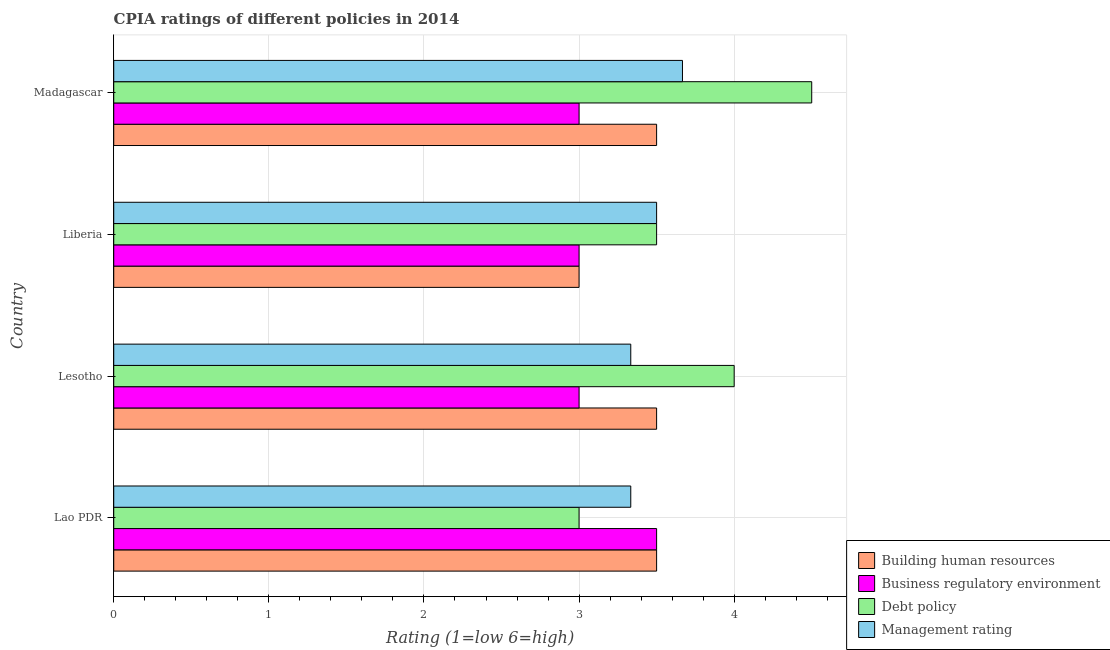How many different coloured bars are there?
Keep it short and to the point. 4. How many bars are there on the 3rd tick from the bottom?
Offer a terse response. 4. What is the label of the 1st group of bars from the top?
Your response must be concise. Madagascar. In how many cases, is the number of bars for a given country not equal to the number of legend labels?
Your response must be concise. 0. What is the cpia rating of building human resources in Lesotho?
Give a very brief answer. 3.5. Across all countries, what is the maximum cpia rating of business regulatory environment?
Give a very brief answer. 3.5. Across all countries, what is the minimum cpia rating of debt policy?
Provide a succinct answer. 3. In which country was the cpia rating of debt policy maximum?
Your response must be concise. Madagascar. In which country was the cpia rating of business regulatory environment minimum?
Offer a very short reply. Lesotho. What is the total cpia rating of management in the graph?
Give a very brief answer. 13.83. What is the difference between the cpia rating of building human resources in Lesotho and that in Liberia?
Your answer should be compact. 0.5. What is the difference between the cpia rating of debt policy in Madagascar and the cpia rating of business regulatory environment in Liberia?
Offer a terse response. 1.5. What is the average cpia rating of building human resources per country?
Give a very brief answer. 3.38. In how many countries, is the cpia rating of management greater than 3.6 ?
Offer a terse response. 1. What is the ratio of the cpia rating of building human resources in Lao PDR to that in Madagascar?
Give a very brief answer. 1. Is the cpia rating of debt policy in Lesotho less than that in Madagascar?
Your answer should be compact. Yes. Is the difference between the cpia rating of building human resources in Lesotho and Madagascar greater than the difference between the cpia rating of management in Lesotho and Madagascar?
Your answer should be compact. Yes. Is it the case that in every country, the sum of the cpia rating of debt policy and cpia rating of building human resources is greater than the sum of cpia rating of management and cpia rating of business regulatory environment?
Your answer should be very brief. No. What does the 3rd bar from the top in Lesotho represents?
Give a very brief answer. Business regulatory environment. What does the 1st bar from the bottom in Liberia represents?
Your response must be concise. Building human resources. Are all the bars in the graph horizontal?
Make the answer very short. Yes. How many countries are there in the graph?
Provide a succinct answer. 4. Does the graph contain any zero values?
Your response must be concise. No. How are the legend labels stacked?
Your answer should be very brief. Vertical. What is the title of the graph?
Keep it short and to the point. CPIA ratings of different policies in 2014. What is the label or title of the X-axis?
Provide a short and direct response. Rating (1=low 6=high). What is the label or title of the Y-axis?
Provide a succinct answer. Country. What is the Rating (1=low 6=high) of Management rating in Lao PDR?
Give a very brief answer. 3.33. What is the Rating (1=low 6=high) of Business regulatory environment in Lesotho?
Your answer should be very brief. 3. What is the Rating (1=low 6=high) of Debt policy in Lesotho?
Provide a succinct answer. 4. What is the Rating (1=low 6=high) of Management rating in Lesotho?
Provide a succinct answer. 3.33. What is the Rating (1=low 6=high) in Business regulatory environment in Liberia?
Your answer should be compact. 3. What is the Rating (1=low 6=high) in Debt policy in Liberia?
Make the answer very short. 3.5. What is the Rating (1=low 6=high) of Management rating in Liberia?
Your answer should be very brief. 3.5. What is the Rating (1=low 6=high) in Management rating in Madagascar?
Offer a terse response. 3.67. Across all countries, what is the maximum Rating (1=low 6=high) of Management rating?
Keep it short and to the point. 3.67. Across all countries, what is the minimum Rating (1=low 6=high) in Debt policy?
Provide a succinct answer. 3. Across all countries, what is the minimum Rating (1=low 6=high) of Management rating?
Your answer should be very brief. 3.33. What is the total Rating (1=low 6=high) in Building human resources in the graph?
Provide a succinct answer. 13.5. What is the total Rating (1=low 6=high) in Business regulatory environment in the graph?
Keep it short and to the point. 12.5. What is the total Rating (1=low 6=high) of Debt policy in the graph?
Ensure brevity in your answer.  15. What is the total Rating (1=low 6=high) in Management rating in the graph?
Your answer should be very brief. 13.83. What is the difference between the Rating (1=low 6=high) in Business regulatory environment in Lao PDR and that in Lesotho?
Your response must be concise. 0.5. What is the difference between the Rating (1=low 6=high) in Business regulatory environment in Lao PDR and that in Liberia?
Provide a succinct answer. 0.5. What is the difference between the Rating (1=low 6=high) in Management rating in Lao PDR and that in Liberia?
Keep it short and to the point. -0.17. What is the difference between the Rating (1=low 6=high) in Building human resources in Lao PDR and that in Madagascar?
Offer a very short reply. 0. What is the difference between the Rating (1=low 6=high) of Business regulatory environment in Lao PDR and that in Madagascar?
Your answer should be compact. 0.5. What is the difference between the Rating (1=low 6=high) of Debt policy in Lao PDR and that in Madagascar?
Keep it short and to the point. -1.5. What is the difference between the Rating (1=low 6=high) of Building human resources in Lesotho and that in Liberia?
Keep it short and to the point. 0.5. What is the difference between the Rating (1=low 6=high) in Building human resources in Lesotho and that in Madagascar?
Your answer should be very brief. 0. What is the difference between the Rating (1=low 6=high) in Business regulatory environment in Lesotho and that in Madagascar?
Provide a short and direct response. 0. What is the difference between the Rating (1=low 6=high) of Debt policy in Lesotho and that in Madagascar?
Provide a short and direct response. -0.5. What is the difference between the Rating (1=low 6=high) in Business regulatory environment in Liberia and that in Madagascar?
Make the answer very short. 0. What is the difference between the Rating (1=low 6=high) in Building human resources in Lao PDR and the Rating (1=low 6=high) in Business regulatory environment in Lesotho?
Offer a terse response. 0.5. What is the difference between the Rating (1=low 6=high) of Building human resources in Lao PDR and the Rating (1=low 6=high) of Debt policy in Lesotho?
Make the answer very short. -0.5. What is the difference between the Rating (1=low 6=high) of Business regulatory environment in Lao PDR and the Rating (1=low 6=high) of Management rating in Lesotho?
Make the answer very short. 0.17. What is the difference between the Rating (1=low 6=high) in Debt policy in Lao PDR and the Rating (1=low 6=high) in Management rating in Lesotho?
Ensure brevity in your answer.  -0.33. What is the difference between the Rating (1=low 6=high) in Building human resources in Lao PDR and the Rating (1=low 6=high) in Business regulatory environment in Liberia?
Keep it short and to the point. 0.5. What is the difference between the Rating (1=low 6=high) of Building human resources in Lao PDR and the Rating (1=low 6=high) of Debt policy in Liberia?
Offer a very short reply. 0. What is the difference between the Rating (1=low 6=high) in Building human resources in Lao PDR and the Rating (1=low 6=high) in Management rating in Liberia?
Keep it short and to the point. 0. What is the difference between the Rating (1=low 6=high) of Business regulatory environment in Lao PDR and the Rating (1=low 6=high) of Debt policy in Liberia?
Offer a terse response. 0. What is the difference between the Rating (1=low 6=high) in Debt policy in Lao PDR and the Rating (1=low 6=high) in Management rating in Liberia?
Your response must be concise. -0.5. What is the difference between the Rating (1=low 6=high) of Building human resources in Lao PDR and the Rating (1=low 6=high) of Business regulatory environment in Madagascar?
Give a very brief answer. 0.5. What is the difference between the Rating (1=low 6=high) in Building human resources in Lao PDR and the Rating (1=low 6=high) in Debt policy in Madagascar?
Ensure brevity in your answer.  -1. What is the difference between the Rating (1=low 6=high) of Business regulatory environment in Lao PDR and the Rating (1=low 6=high) of Management rating in Madagascar?
Offer a very short reply. -0.17. What is the difference between the Rating (1=low 6=high) of Debt policy in Lao PDR and the Rating (1=low 6=high) of Management rating in Madagascar?
Provide a short and direct response. -0.67. What is the difference between the Rating (1=low 6=high) of Building human resources in Lesotho and the Rating (1=low 6=high) of Debt policy in Liberia?
Keep it short and to the point. 0. What is the difference between the Rating (1=low 6=high) in Business regulatory environment in Lesotho and the Rating (1=low 6=high) in Management rating in Liberia?
Give a very brief answer. -0.5. What is the difference between the Rating (1=low 6=high) of Building human resources in Lesotho and the Rating (1=low 6=high) of Debt policy in Madagascar?
Make the answer very short. -1. What is the difference between the Rating (1=low 6=high) in Business regulatory environment in Lesotho and the Rating (1=low 6=high) in Management rating in Madagascar?
Provide a succinct answer. -0.67. What is the difference between the Rating (1=low 6=high) of Building human resources in Liberia and the Rating (1=low 6=high) of Debt policy in Madagascar?
Make the answer very short. -1.5. What is the difference between the Rating (1=low 6=high) in Business regulatory environment in Liberia and the Rating (1=low 6=high) in Management rating in Madagascar?
Your answer should be very brief. -0.67. What is the difference between the Rating (1=low 6=high) in Debt policy in Liberia and the Rating (1=low 6=high) in Management rating in Madagascar?
Your answer should be compact. -0.17. What is the average Rating (1=low 6=high) in Building human resources per country?
Your answer should be compact. 3.38. What is the average Rating (1=low 6=high) in Business regulatory environment per country?
Offer a very short reply. 3.12. What is the average Rating (1=low 6=high) in Debt policy per country?
Make the answer very short. 3.75. What is the average Rating (1=low 6=high) in Management rating per country?
Your answer should be compact. 3.46. What is the difference between the Rating (1=low 6=high) in Building human resources and Rating (1=low 6=high) in Business regulatory environment in Lao PDR?
Give a very brief answer. 0. What is the difference between the Rating (1=low 6=high) in Building human resources and Rating (1=low 6=high) in Management rating in Lao PDR?
Your answer should be very brief. 0.17. What is the difference between the Rating (1=low 6=high) in Business regulatory environment and Rating (1=low 6=high) in Management rating in Lao PDR?
Offer a terse response. 0.17. What is the difference between the Rating (1=low 6=high) of Debt policy and Rating (1=low 6=high) of Management rating in Lao PDR?
Offer a very short reply. -0.33. What is the difference between the Rating (1=low 6=high) of Building human resources and Rating (1=low 6=high) of Business regulatory environment in Lesotho?
Offer a terse response. 0.5. What is the difference between the Rating (1=low 6=high) in Business regulatory environment and Rating (1=low 6=high) in Debt policy in Lesotho?
Make the answer very short. -1. What is the difference between the Rating (1=low 6=high) of Debt policy and Rating (1=low 6=high) of Management rating in Lesotho?
Keep it short and to the point. 0.67. What is the difference between the Rating (1=low 6=high) in Building human resources and Rating (1=low 6=high) in Business regulatory environment in Liberia?
Keep it short and to the point. 0. What is the difference between the Rating (1=low 6=high) in Building human resources and Rating (1=low 6=high) in Debt policy in Liberia?
Your answer should be compact. -0.5. What is the difference between the Rating (1=low 6=high) of Building human resources and Rating (1=low 6=high) of Management rating in Liberia?
Your answer should be compact. -0.5. What is the difference between the Rating (1=low 6=high) of Business regulatory environment and Rating (1=low 6=high) of Management rating in Liberia?
Provide a short and direct response. -0.5. What is the difference between the Rating (1=low 6=high) of Debt policy and Rating (1=low 6=high) of Management rating in Liberia?
Your answer should be compact. 0. What is the difference between the Rating (1=low 6=high) of Building human resources and Rating (1=low 6=high) of Management rating in Madagascar?
Make the answer very short. -0.17. What is the difference between the Rating (1=low 6=high) of Business regulatory environment and Rating (1=low 6=high) of Management rating in Madagascar?
Offer a very short reply. -0.67. What is the difference between the Rating (1=low 6=high) of Debt policy and Rating (1=low 6=high) of Management rating in Madagascar?
Keep it short and to the point. 0.83. What is the ratio of the Rating (1=low 6=high) in Building human resources in Lao PDR to that in Lesotho?
Give a very brief answer. 1. What is the ratio of the Rating (1=low 6=high) in Debt policy in Lao PDR to that in Lesotho?
Your answer should be compact. 0.75. What is the ratio of the Rating (1=low 6=high) of Management rating in Lao PDR to that in Lesotho?
Keep it short and to the point. 1. What is the ratio of the Rating (1=low 6=high) of Building human resources in Lao PDR to that in Liberia?
Your answer should be compact. 1.17. What is the ratio of the Rating (1=low 6=high) in Debt policy in Lao PDR to that in Liberia?
Give a very brief answer. 0.86. What is the ratio of the Rating (1=low 6=high) in Debt policy in Lao PDR to that in Madagascar?
Offer a terse response. 0.67. What is the ratio of the Rating (1=low 6=high) in Business regulatory environment in Lesotho to that in Liberia?
Offer a terse response. 1. What is the ratio of the Rating (1=low 6=high) in Building human resources in Lesotho to that in Madagascar?
Your answer should be compact. 1. What is the ratio of the Rating (1=low 6=high) of Management rating in Lesotho to that in Madagascar?
Your response must be concise. 0.91. What is the ratio of the Rating (1=low 6=high) of Building human resources in Liberia to that in Madagascar?
Your answer should be very brief. 0.86. What is the ratio of the Rating (1=low 6=high) in Debt policy in Liberia to that in Madagascar?
Provide a succinct answer. 0.78. What is the ratio of the Rating (1=low 6=high) in Management rating in Liberia to that in Madagascar?
Provide a succinct answer. 0.95. What is the difference between the highest and the second highest Rating (1=low 6=high) in Business regulatory environment?
Your answer should be very brief. 0.5. What is the difference between the highest and the second highest Rating (1=low 6=high) in Debt policy?
Keep it short and to the point. 0.5. What is the difference between the highest and the lowest Rating (1=low 6=high) in Building human resources?
Offer a very short reply. 0.5. What is the difference between the highest and the lowest Rating (1=low 6=high) of Debt policy?
Your answer should be compact. 1.5. 